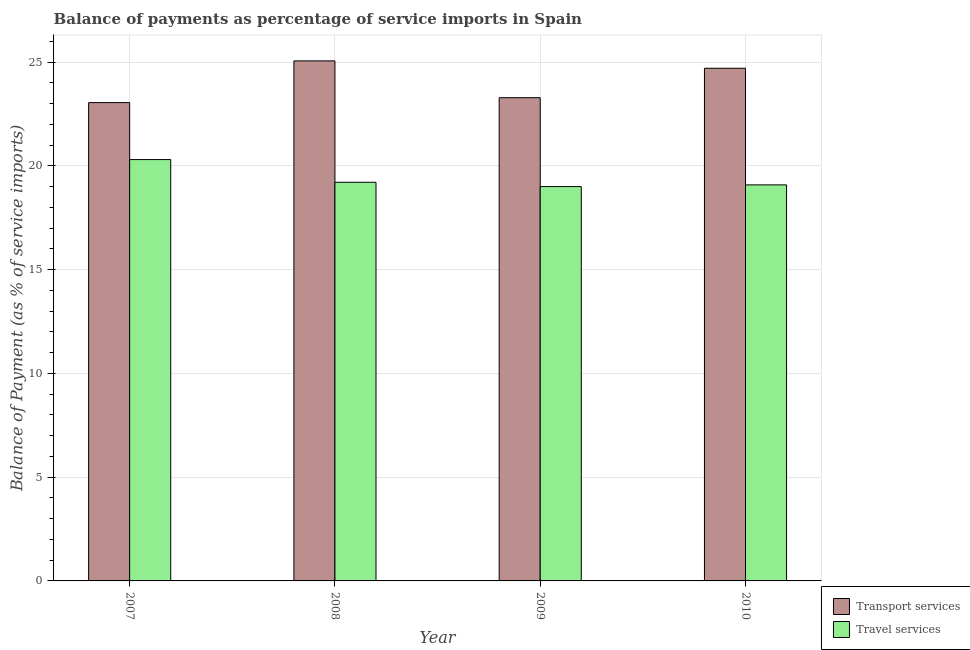How many different coloured bars are there?
Your answer should be compact. 2. How many groups of bars are there?
Your answer should be compact. 4. Are the number of bars per tick equal to the number of legend labels?
Your answer should be compact. Yes. Are the number of bars on each tick of the X-axis equal?
Make the answer very short. Yes. What is the label of the 1st group of bars from the left?
Make the answer very short. 2007. In how many cases, is the number of bars for a given year not equal to the number of legend labels?
Provide a short and direct response. 0. What is the balance of payments of travel services in 2009?
Provide a short and direct response. 19.01. Across all years, what is the maximum balance of payments of transport services?
Offer a terse response. 25.06. Across all years, what is the minimum balance of payments of travel services?
Ensure brevity in your answer.  19.01. What is the total balance of payments of transport services in the graph?
Offer a very short reply. 96.11. What is the difference between the balance of payments of transport services in 2007 and that in 2008?
Your answer should be very brief. -2.01. What is the difference between the balance of payments of transport services in 2009 and the balance of payments of travel services in 2007?
Provide a short and direct response. 0.24. What is the average balance of payments of transport services per year?
Ensure brevity in your answer.  24.03. In the year 2008, what is the difference between the balance of payments of travel services and balance of payments of transport services?
Provide a succinct answer. 0. What is the ratio of the balance of payments of transport services in 2008 to that in 2009?
Keep it short and to the point. 1.08. Is the balance of payments of transport services in 2007 less than that in 2010?
Offer a terse response. Yes. What is the difference between the highest and the second highest balance of payments of travel services?
Your response must be concise. 1.09. What is the difference between the highest and the lowest balance of payments of travel services?
Provide a succinct answer. 1.3. In how many years, is the balance of payments of travel services greater than the average balance of payments of travel services taken over all years?
Provide a succinct answer. 1. Is the sum of the balance of payments of transport services in 2007 and 2010 greater than the maximum balance of payments of travel services across all years?
Your response must be concise. Yes. What does the 1st bar from the left in 2008 represents?
Offer a very short reply. Transport services. What does the 2nd bar from the right in 2008 represents?
Provide a succinct answer. Transport services. How many years are there in the graph?
Offer a terse response. 4. What is the difference between two consecutive major ticks on the Y-axis?
Ensure brevity in your answer.  5. Are the values on the major ticks of Y-axis written in scientific E-notation?
Provide a short and direct response. No. Does the graph contain grids?
Ensure brevity in your answer.  Yes. Where does the legend appear in the graph?
Make the answer very short. Bottom right. How many legend labels are there?
Keep it short and to the point. 2. What is the title of the graph?
Make the answer very short. Balance of payments as percentage of service imports in Spain. Does "Chemicals" appear as one of the legend labels in the graph?
Offer a very short reply. No. What is the label or title of the Y-axis?
Keep it short and to the point. Balance of Payment (as % of service imports). What is the Balance of Payment (as % of service imports) in Transport services in 2007?
Make the answer very short. 23.05. What is the Balance of Payment (as % of service imports) of Travel services in 2007?
Give a very brief answer. 20.31. What is the Balance of Payment (as % of service imports) of Transport services in 2008?
Ensure brevity in your answer.  25.06. What is the Balance of Payment (as % of service imports) in Travel services in 2008?
Your response must be concise. 19.21. What is the Balance of Payment (as % of service imports) of Transport services in 2009?
Your response must be concise. 23.29. What is the Balance of Payment (as % of service imports) in Travel services in 2009?
Your answer should be very brief. 19.01. What is the Balance of Payment (as % of service imports) in Transport services in 2010?
Keep it short and to the point. 24.71. What is the Balance of Payment (as % of service imports) of Travel services in 2010?
Your response must be concise. 19.09. Across all years, what is the maximum Balance of Payment (as % of service imports) of Transport services?
Offer a terse response. 25.06. Across all years, what is the maximum Balance of Payment (as % of service imports) of Travel services?
Your response must be concise. 20.31. Across all years, what is the minimum Balance of Payment (as % of service imports) of Transport services?
Your answer should be very brief. 23.05. Across all years, what is the minimum Balance of Payment (as % of service imports) in Travel services?
Make the answer very short. 19.01. What is the total Balance of Payment (as % of service imports) of Transport services in the graph?
Offer a terse response. 96.11. What is the total Balance of Payment (as % of service imports) in Travel services in the graph?
Make the answer very short. 77.61. What is the difference between the Balance of Payment (as % of service imports) of Transport services in 2007 and that in 2008?
Your response must be concise. -2.01. What is the difference between the Balance of Payment (as % of service imports) in Travel services in 2007 and that in 2008?
Ensure brevity in your answer.  1.09. What is the difference between the Balance of Payment (as % of service imports) in Transport services in 2007 and that in 2009?
Your answer should be compact. -0.24. What is the difference between the Balance of Payment (as % of service imports) in Travel services in 2007 and that in 2009?
Ensure brevity in your answer.  1.3. What is the difference between the Balance of Payment (as % of service imports) of Transport services in 2007 and that in 2010?
Your answer should be compact. -1.66. What is the difference between the Balance of Payment (as % of service imports) of Travel services in 2007 and that in 2010?
Provide a succinct answer. 1.22. What is the difference between the Balance of Payment (as % of service imports) in Transport services in 2008 and that in 2009?
Provide a short and direct response. 1.77. What is the difference between the Balance of Payment (as % of service imports) in Travel services in 2008 and that in 2009?
Offer a very short reply. 0.21. What is the difference between the Balance of Payment (as % of service imports) in Transport services in 2008 and that in 2010?
Offer a terse response. 0.36. What is the difference between the Balance of Payment (as % of service imports) in Travel services in 2008 and that in 2010?
Offer a terse response. 0.13. What is the difference between the Balance of Payment (as % of service imports) in Transport services in 2009 and that in 2010?
Keep it short and to the point. -1.42. What is the difference between the Balance of Payment (as % of service imports) of Travel services in 2009 and that in 2010?
Offer a very short reply. -0.08. What is the difference between the Balance of Payment (as % of service imports) of Transport services in 2007 and the Balance of Payment (as % of service imports) of Travel services in 2008?
Offer a terse response. 3.84. What is the difference between the Balance of Payment (as % of service imports) of Transport services in 2007 and the Balance of Payment (as % of service imports) of Travel services in 2009?
Offer a very short reply. 4.05. What is the difference between the Balance of Payment (as % of service imports) of Transport services in 2007 and the Balance of Payment (as % of service imports) of Travel services in 2010?
Provide a short and direct response. 3.97. What is the difference between the Balance of Payment (as % of service imports) of Transport services in 2008 and the Balance of Payment (as % of service imports) of Travel services in 2009?
Keep it short and to the point. 6.06. What is the difference between the Balance of Payment (as % of service imports) in Transport services in 2008 and the Balance of Payment (as % of service imports) in Travel services in 2010?
Your answer should be compact. 5.98. What is the difference between the Balance of Payment (as % of service imports) in Transport services in 2009 and the Balance of Payment (as % of service imports) in Travel services in 2010?
Provide a short and direct response. 4.2. What is the average Balance of Payment (as % of service imports) of Transport services per year?
Provide a short and direct response. 24.03. What is the average Balance of Payment (as % of service imports) in Travel services per year?
Keep it short and to the point. 19.4. In the year 2007, what is the difference between the Balance of Payment (as % of service imports) of Transport services and Balance of Payment (as % of service imports) of Travel services?
Give a very brief answer. 2.75. In the year 2008, what is the difference between the Balance of Payment (as % of service imports) of Transport services and Balance of Payment (as % of service imports) of Travel services?
Offer a very short reply. 5.85. In the year 2009, what is the difference between the Balance of Payment (as % of service imports) of Transport services and Balance of Payment (as % of service imports) of Travel services?
Keep it short and to the point. 4.28. In the year 2010, what is the difference between the Balance of Payment (as % of service imports) in Transport services and Balance of Payment (as % of service imports) in Travel services?
Your response must be concise. 5.62. What is the ratio of the Balance of Payment (as % of service imports) of Transport services in 2007 to that in 2008?
Ensure brevity in your answer.  0.92. What is the ratio of the Balance of Payment (as % of service imports) of Travel services in 2007 to that in 2008?
Offer a terse response. 1.06. What is the ratio of the Balance of Payment (as % of service imports) of Travel services in 2007 to that in 2009?
Your answer should be compact. 1.07. What is the ratio of the Balance of Payment (as % of service imports) in Transport services in 2007 to that in 2010?
Your answer should be very brief. 0.93. What is the ratio of the Balance of Payment (as % of service imports) in Travel services in 2007 to that in 2010?
Your response must be concise. 1.06. What is the ratio of the Balance of Payment (as % of service imports) in Transport services in 2008 to that in 2009?
Give a very brief answer. 1.08. What is the ratio of the Balance of Payment (as % of service imports) in Travel services in 2008 to that in 2009?
Make the answer very short. 1.01. What is the ratio of the Balance of Payment (as % of service imports) of Transport services in 2008 to that in 2010?
Give a very brief answer. 1.01. What is the ratio of the Balance of Payment (as % of service imports) of Travel services in 2008 to that in 2010?
Your response must be concise. 1.01. What is the ratio of the Balance of Payment (as % of service imports) of Transport services in 2009 to that in 2010?
Keep it short and to the point. 0.94. What is the ratio of the Balance of Payment (as % of service imports) in Travel services in 2009 to that in 2010?
Ensure brevity in your answer.  1. What is the difference between the highest and the second highest Balance of Payment (as % of service imports) of Transport services?
Your answer should be very brief. 0.36. What is the difference between the highest and the second highest Balance of Payment (as % of service imports) in Travel services?
Keep it short and to the point. 1.09. What is the difference between the highest and the lowest Balance of Payment (as % of service imports) of Transport services?
Offer a very short reply. 2.01. What is the difference between the highest and the lowest Balance of Payment (as % of service imports) of Travel services?
Offer a very short reply. 1.3. 